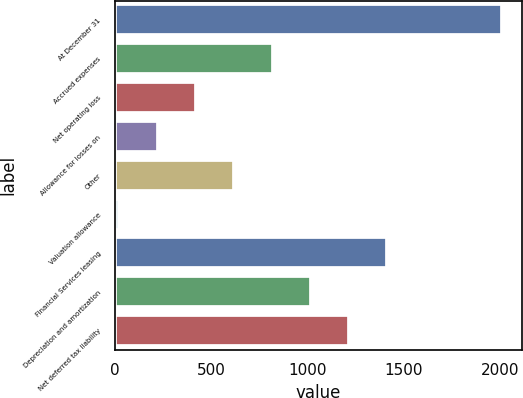<chart> <loc_0><loc_0><loc_500><loc_500><bar_chart><fcel>At December 31<fcel>Accrued expenses<fcel>Net operating loss<fcel>Allowance for losses on<fcel>Other<fcel>Valuation allowance<fcel>Financial Services leasing<fcel>Depreciation and amortization<fcel>Net deferred tax liability<nl><fcel>2012<fcel>817.52<fcel>419.36<fcel>220.28<fcel>618.44<fcel>21.2<fcel>1414.76<fcel>1016.6<fcel>1215.68<nl></chart> 